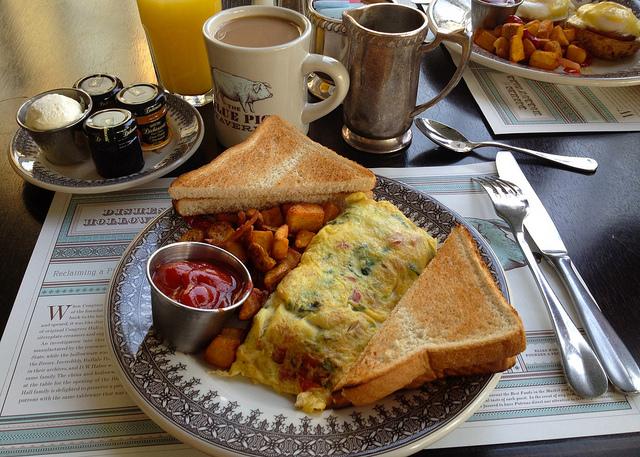What is the creamer pitcher made of?
Short answer required. Metal. Is the butter packaged?
Be succinct. No. How many plates are there?
Write a very short answer. 3. 